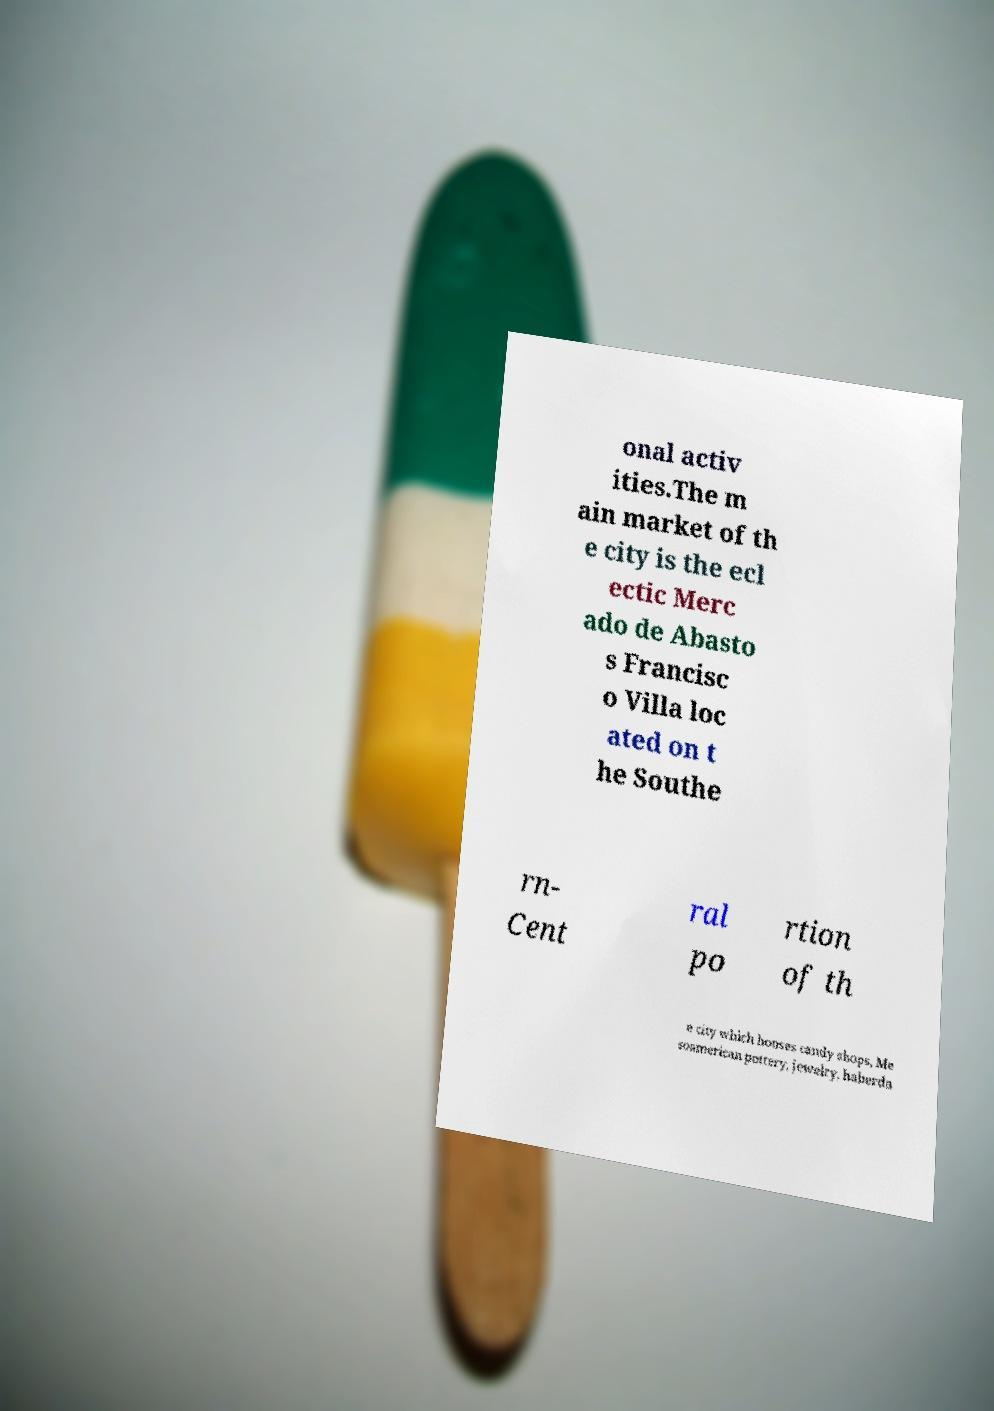I need the written content from this picture converted into text. Can you do that? onal activ ities.The m ain market of th e city is the ecl ectic Merc ado de Abasto s Francisc o Villa loc ated on t he Southe rn- Cent ral po rtion of th e city which houses candy shops, Me soamerican pottery, jewelry, haberda 